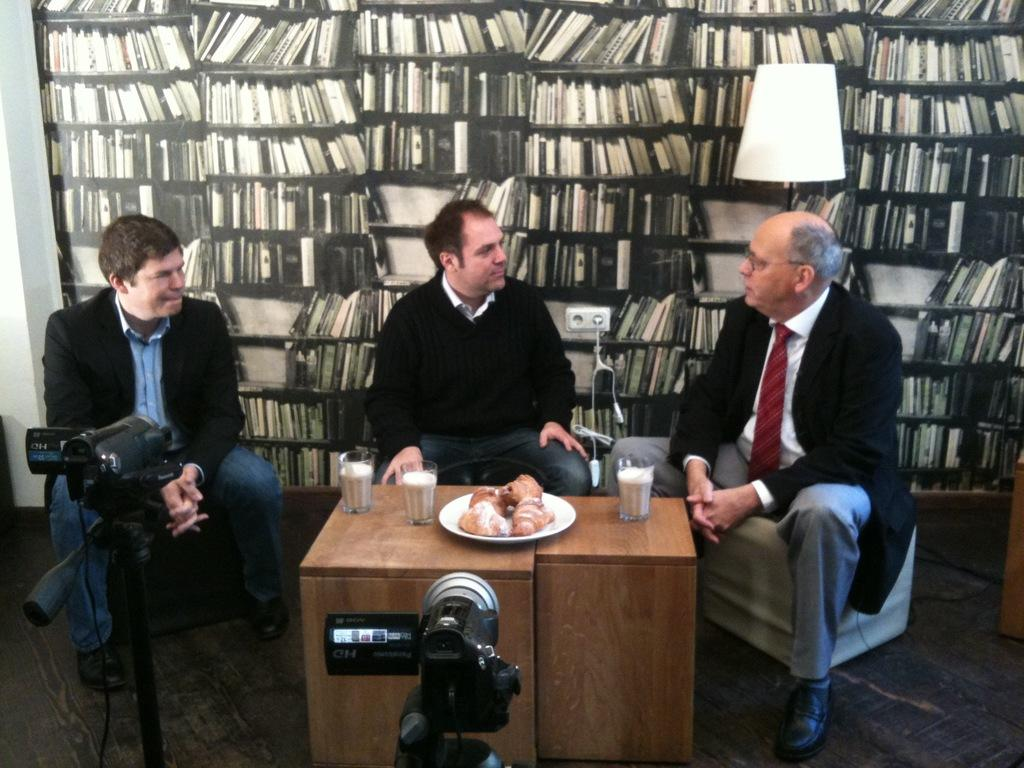How many people are in the image? There are three men in the image. What are the men doing in the image? The men are sitting at a table. What objects can be seen on the table? There are three glasses and a plate with eatables on the table. How is the scene being captured in the image? There are two cameras covering the scene. What type of pipe is being smoked by one of the men in the image? There is no pipe present in the image; the men are not smoking anything. What suggestion is being made by one of the men in the image? There is no conversation or suggestion being made in the image; the men are simply sitting at a table. 